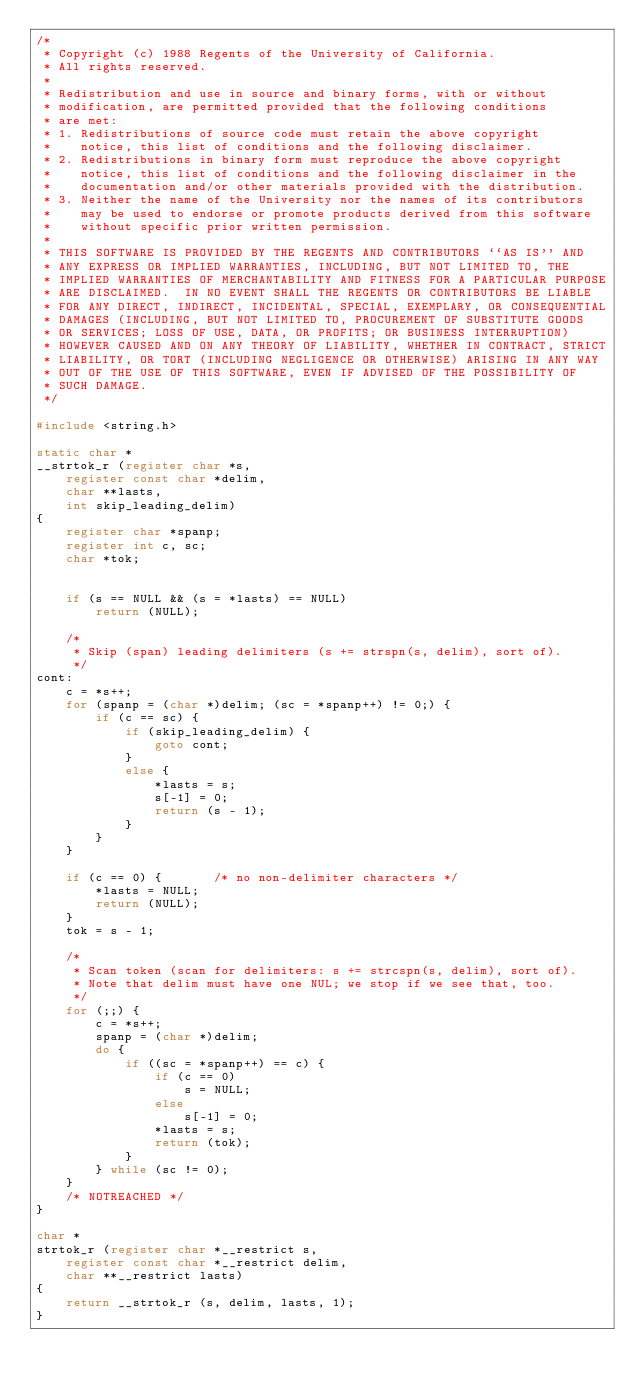Convert code to text. <code><loc_0><loc_0><loc_500><loc_500><_C_>/*
 * Copyright (c) 1988 Regents of the University of California.
 * All rights reserved.
 *
 * Redistribution and use in source and binary forms, with or without
 * modification, are permitted provided that the following conditions
 * are met:
 * 1. Redistributions of source code must retain the above copyright
 *    notice, this list of conditions and the following disclaimer.
 * 2. Redistributions in binary form must reproduce the above copyright
 *    notice, this list of conditions and the following disclaimer in the
 *    documentation and/or other materials provided with the distribution.
 * 3. Neither the name of the University nor the names of its contributors
 *    may be used to endorse or promote products derived from this software
 *    without specific prior written permission.
 *
 * THIS SOFTWARE IS PROVIDED BY THE REGENTS AND CONTRIBUTORS ``AS IS'' AND
 * ANY EXPRESS OR IMPLIED WARRANTIES, INCLUDING, BUT NOT LIMITED TO, THE
 * IMPLIED WARRANTIES OF MERCHANTABILITY AND FITNESS FOR A PARTICULAR PURPOSE
 * ARE DISCLAIMED.  IN NO EVENT SHALL THE REGENTS OR CONTRIBUTORS BE LIABLE
 * FOR ANY DIRECT, INDIRECT, INCIDENTAL, SPECIAL, EXEMPLARY, OR CONSEQUENTIAL
 * DAMAGES (INCLUDING, BUT NOT LIMITED TO, PROCUREMENT OF SUBSTITUTE GOODS
 * OR SERVICES; LOSS OF USE, DATA, OR PROFITS; OR BUSINESS INTERRUPTION)
 * HOWEVER CAUSED AND ON ANY THEORY OF LIABILITY, WHETHER IN CONTRACT, STRICT
 * LIABILITY, OR TORT (INCLUDING NEGLIGENCE OR OTHERWISE) ARISING IN ANY WAY
 * OUT OF THE USE OF THIS SOFTWARE, EVEN IF ADVISED OF THE POSSIBILITY OF
 * SUCH DAMAGE.
 */

#include <string.h>

static char *
__strtok_r (register char *s,
	register const char *delim,
	char **lasts,
	int skip_leading_delim)
{
	register char *spanp;
	register int c, sc;
	char *tok;


	if (s == NULL && (s = *lasts) == NULL)
		return (NULL);

	/*
	 * Skip (span) leading delimiters (s += strspn(s, delim), sort of).
	 */
cont:
	c = *s++;
	for (spanp = (char *)delim; (sc = *spanp++) != 0;) {
		if (c == sc) {
			if (skip_leading_delim) {
				goto cont;
			}
			else {
				*lasts = s;
				s[-1] = 0;
				return (s - 1);
			}
		}
	}

	if (c == 0) {		/* no non-delimiter characters */
		*lasts = NULL;
		return (NULL);
	}
	tok = s - 1;

	/*
	 * Scan token (scan for delimiters: s += strcspn(s, delim), sort of).
	 * Note that delim must have one NUL; we stop if we see that, too.
	 */
	for (;;) {
		c = *s++;
		spanp = (char *)delim;
		do {
			if ((sc = *spanp++) == c) {
				if (c == 0)
					s = NULL;
				else
					s[-1] = 0;
				*lasts = s;
				return (tok);
			}
		} while (sc != 0);
	}
	/* NOTREACHED */
}

char *
strtok_r (register char *__restrict s,
	register const char *__restrict delim,
	char **__restrict lasts)
{
	return __strtok_r (s, delim, lasts, 1);
}
</code> 